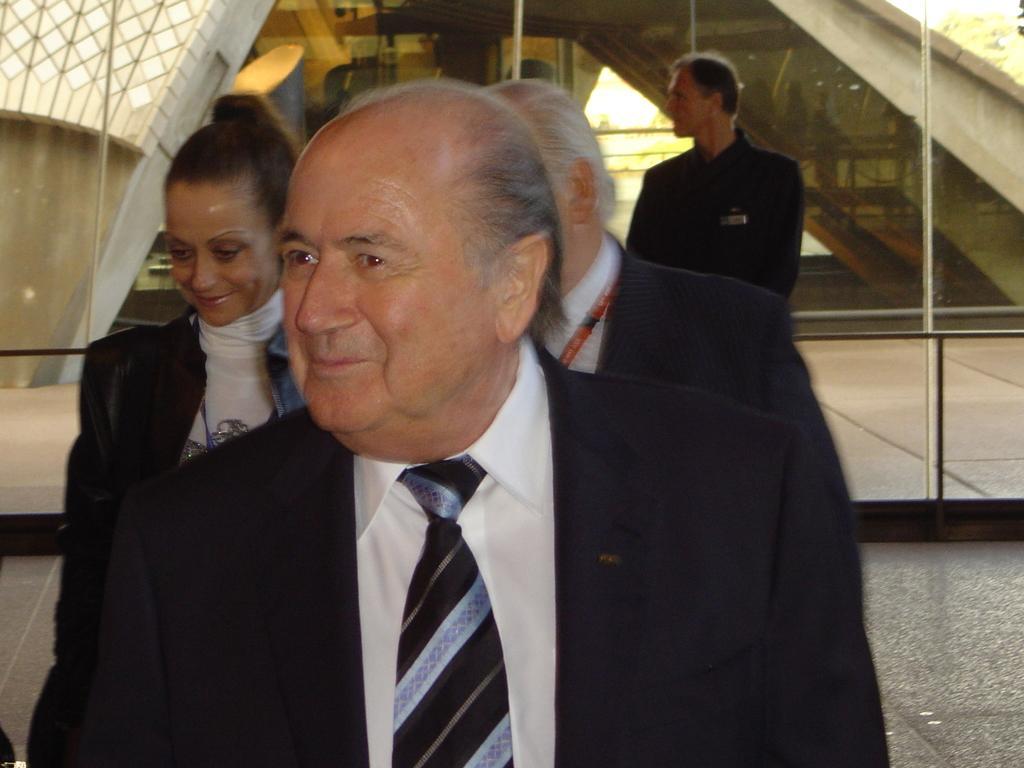Please provide a concise description of this image. In the background we can see the glass wall. Through the glass wall we can see the walls, a person, few objects are visible and a tree. In this picture we can see the people. We can see a man and a woman, they both are smiling. On the right side of the picture we can see the floor. 